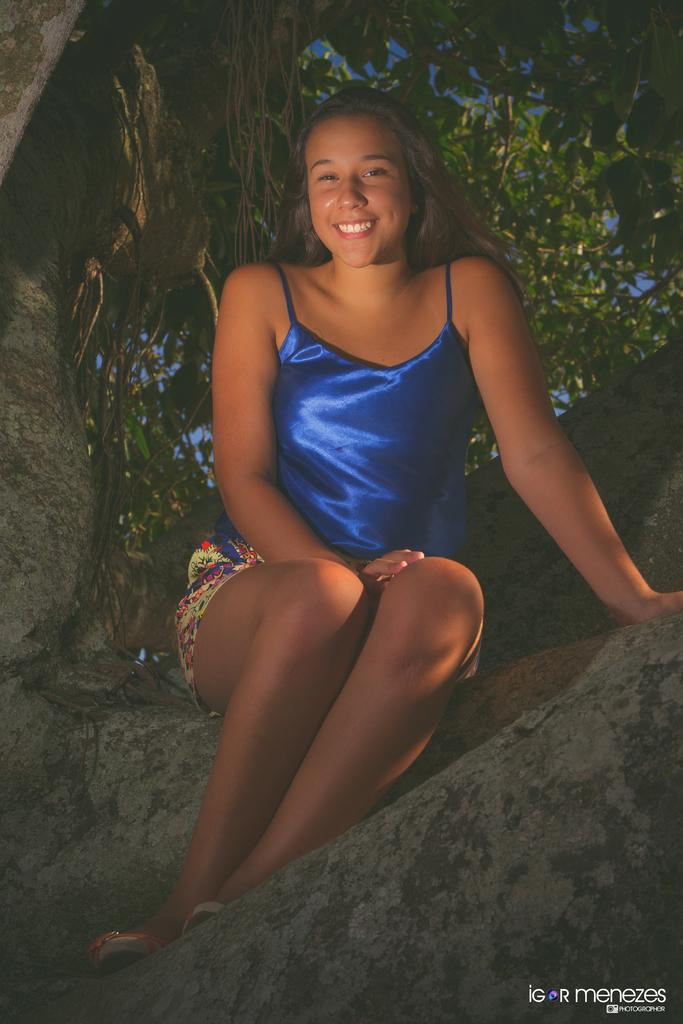Who is present in the image? There is a woman in the image. What is the woman doing in the image? The woman is sitting on a rock slope. What is the woman wearing in the image? The woman is wearing a blue top. What is the woman's facial expression in the image? The woman is smiling. What can be seen in the background of the image? There is a tree visible in the background of the image. What type of desk can be seen in the image? There is no desk present in the image. How does the woman turn around in the image? The woman is not turning around in the image; she is sitting on a rock slope. 